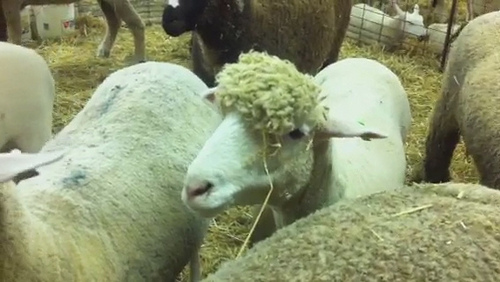Can you describe the pen in more detail? The pen is a large enclosed area with sturdy wire fencing, ensuring the sheep have plenty of space but remain secure. The ground is covered with a thick layer of straw, providing a soft and comfortable surface for the sheep to rest and graze upon. The surrounding area is open, likely part of a larger farm setup. Other sheep are visible, creating a sense of community among the animals. The environmental setup seems well-maintained, indicative of thoughtful care by the farm's keepers. 